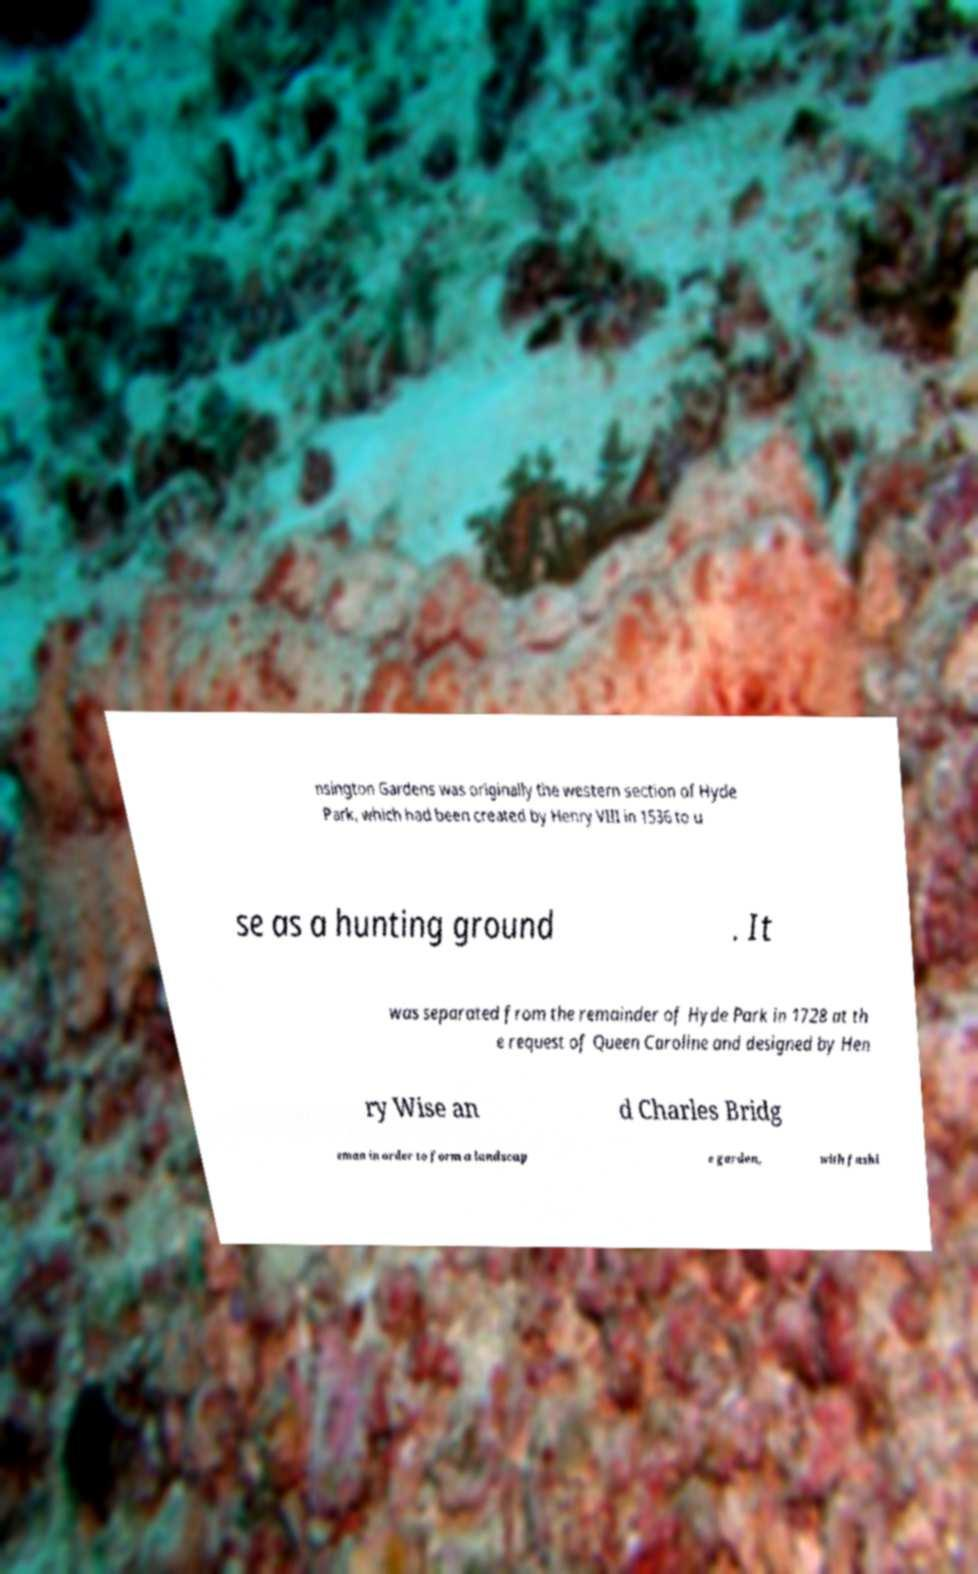There's text embedded in this image that I need extracted. Can you transcribe it verbatim? nsington Gardens was originally the western section of Hyde Park, which had been created by Henry VIII in 1536 to u se as a hunting ground . It was separated from the remainder of Hyde Park in 1728 at th e request of Queen Caroline and designed by Hen ry Wise an d Charles Bridg eman in order to form a landscap e garden, with fashi 